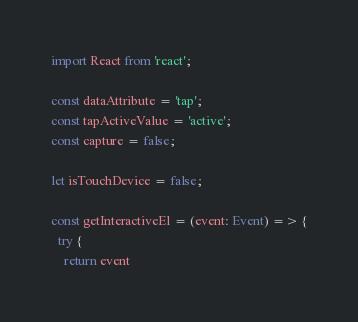<code> <loc_0><loc_0><loc_500><loc_500><_TypeScript_>import React from 'react';

const dataAttribute = 'tap';
const tapActiveValue = 'active';
const capture = false;

let isTouchDevice = false;

const getInteractiveEl = (event: Event) => {
  try {
    return event</code> 